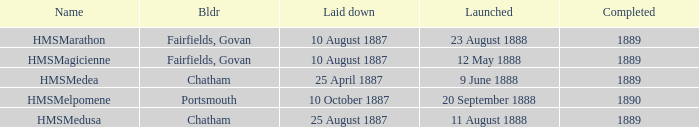What is the name of the boat that was built by Chatham and Laid down of 25 april 1887? HMSMedea. 